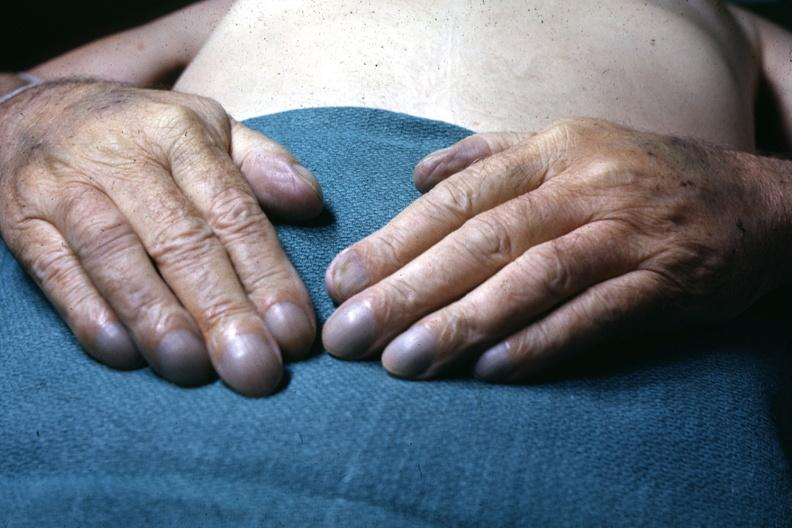s tuberculosis present?
Answer the question using a single word or phrase. No 